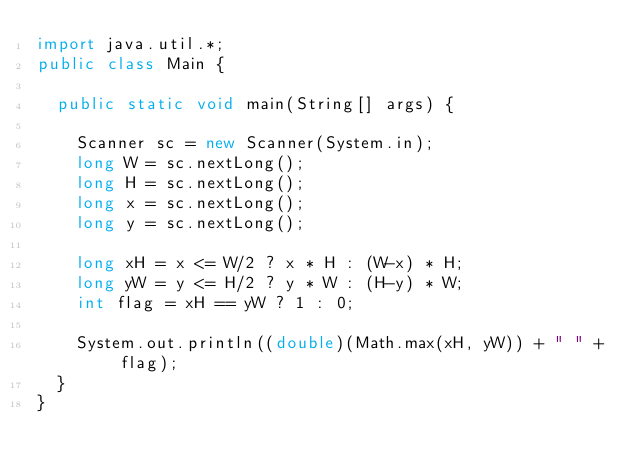Convert code to text. <code><loc_0><loc_0><loc_500><loc_500><_Java_>import java.util.*;
public class Main {
  
  public static void main(String[] args) {

    Scanner sc = new Scanner(System.in);
    long W = sc.nextLong();
    long H = sc.nextLong();
    long x = sc.nextLong();
    long y = sc.nextLong();

    long xH = x <= W/2 ? x * H : (W-x) * H;
    long yW = y <= H/2 ? y * W : (H-y) * W;
    int flag = xH == yW ? 1 : 0;

    System.out.println((double)(Math.max(xH, yW)) + " " + flag);
  }
}
</code> 